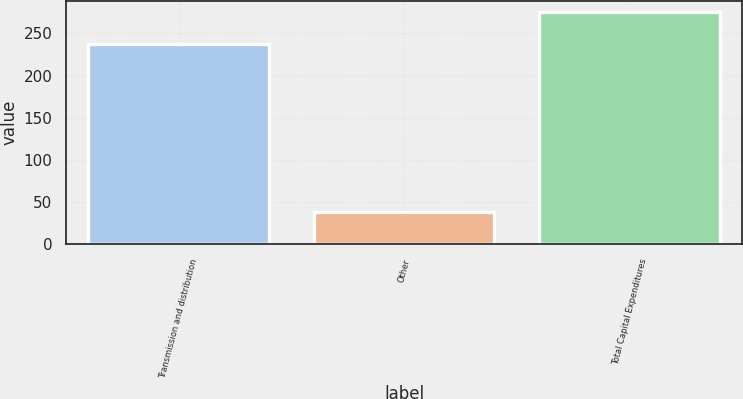Convert chart. <chart><loc_0><loc_0><loc_500><loc_500><bar_chart><fcel>Transmission and distribution<fcel>Other<fcel>Total Capital Expenditures<nl><fcel>237<fcel>38<fcel>275<nl></chart> 